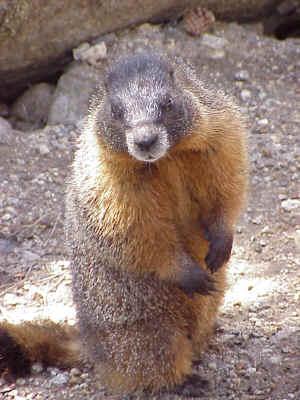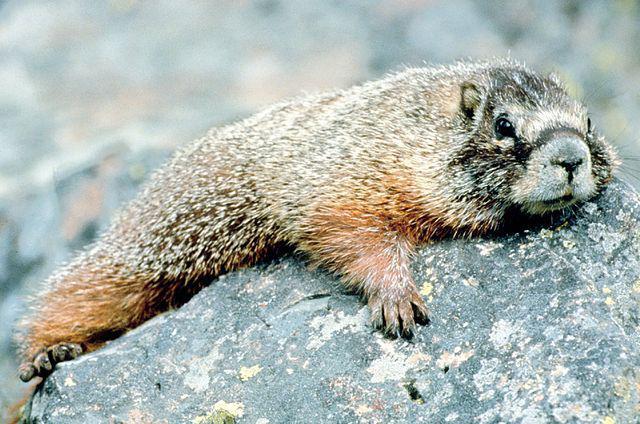The first image is the image on the left, the second image is the image on the right. For the images shown, is this caption "In one of the images, there is a marmot standing up on its hind legs" true? Answer yes or no. Yes. 